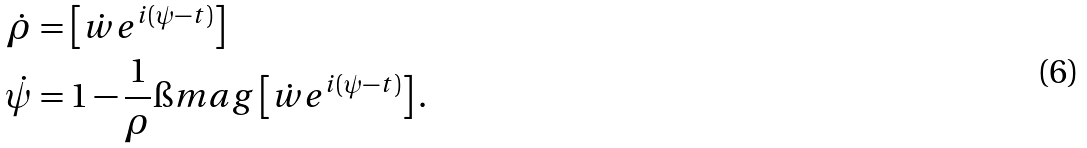<formula> <loc_0><loc_0><loc_500><loc_500>\dot { \rho } & = \real \left [ \dot { w } e ^ { i ( \psi - t ) } \right ] \\ \dot { \psi } & = 1 - \frac { 1 } { \rho } \i m a g \left [ \dot { w } e ^ { i ( \psi - t ) } \right ] .</formula> 